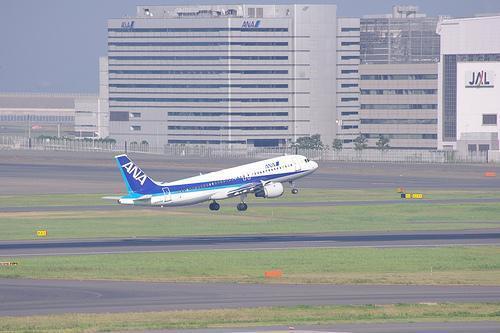How many visible buildings are in the picture?
Give a very brief answer. 4. How many pathways are there in the picture?
Give a very brief answer. 4. 